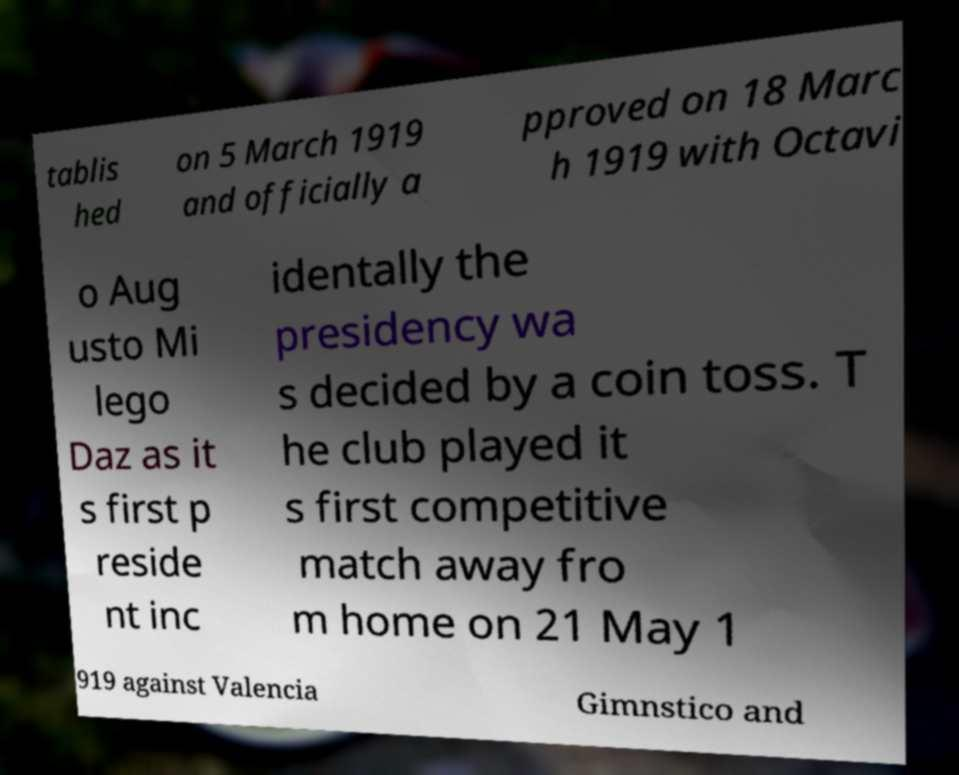Can you accurately transcribe the text from the provided image for me? tablis hed on 5 March 1919 and officially a pproved on 18 Marc h 1919 with Octavi o Aug usto Mi lego Daz as it s first p reside nt inc identally the presidency wa s decided by a coin toss. T he club played it s first competitive match away fro m home on 21 May 1 919 against Valencia Gimnstico and 